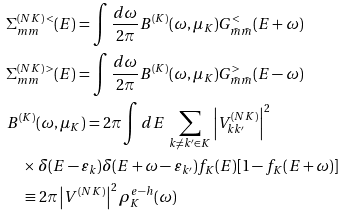Convert formula to latex. <formula><loc_0><loc_0><loc_500><loc_500>& \Sigma ^ { ( N K ) \, < } _ { m m } ( E ) = \int \frac { d \omega } { 2 \pi } B ^ { ( K ) } ( \omega , \mu _ { K } ) G _ { \bar { m } \bar { m } } ^ { < } ( E + \omega ) \\ & \Sigma ^ { ( N K ) \, > } _ { m m } ( E ) = \int \frac { d \omega } { 2 \pi } B ^ { ( K ) } ( \omega , \mu _ { K } ) G _ { \bar { m } \bar { m } } ^ { > } ( E - \omega ) \\ & B ^ { ( K ) } ( \omega , \mu _ { K } ) = 2 \pi \int d E \, \sum _ { k \neq k ^ { \prime } \in K } \left | V _ { k k ^ { \prime } } ^ { ( N K ) } \right | ^ { 2 } \\ & \quad \times \delta ( E - \varepsilon _ { k } ) \delta ( E + \omega - \varepsilon _ { k ^ { \prime } } ) f _ { K } ( E ) [ 1 - f _ { K } ( E + \omega ) ] \\ & \quad \equiv 2 \pi \left | V ^ { ( N K ) } \right | ^ { 2 } \rho _ { K } ^ { e - h } ( \omega )</formula> 